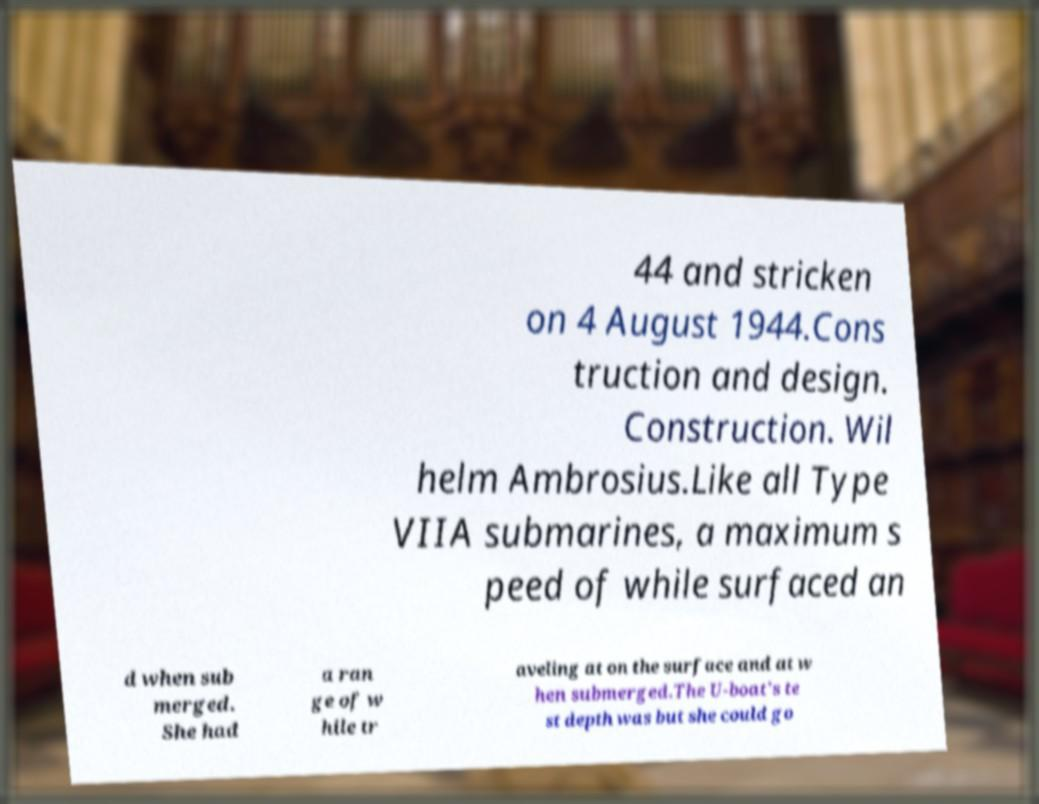Could you extract and type out the text from this image? 44 and stricken on 4 August 1944.Cons truction and design. Construction. Wil helm Ambrosius.Like all Type VIIA submarines, a maximum s peed of while surfaced an d when sub merged. She had a ran ge of w hile tr aveling at on the surface and at w hen submerged.The U-boat's te st depth was but she could go 